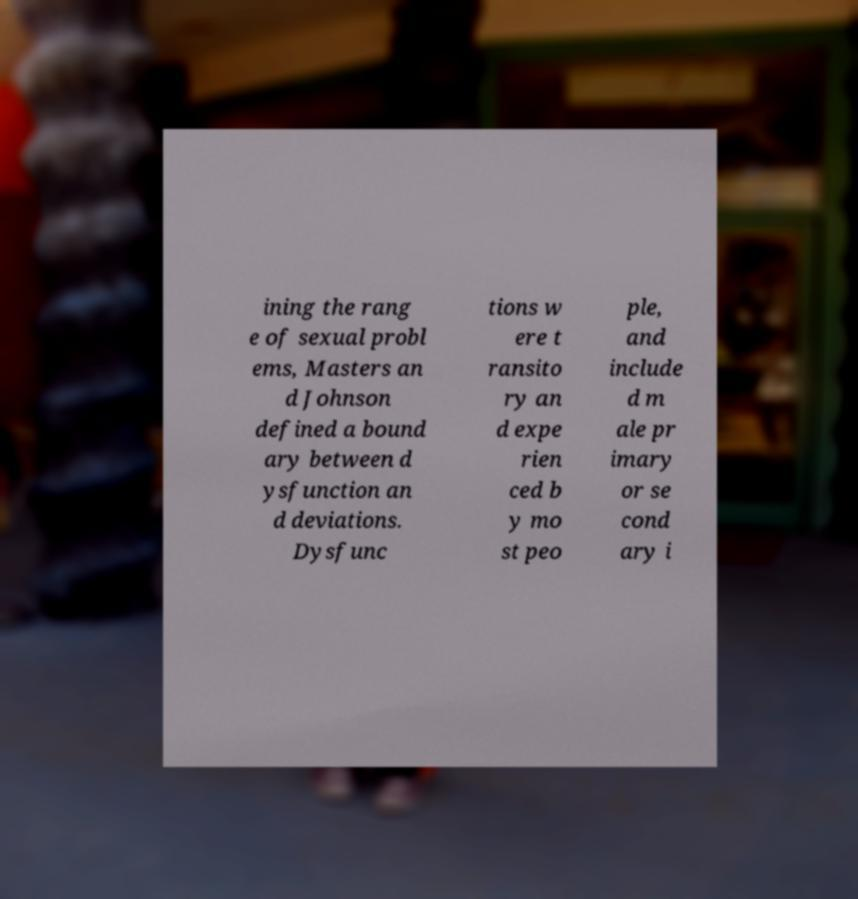Can you read and provide the text displayed in the image?This photo seems to have some interesting text. Can you extract and type it out for me? ining the rang e of sexual probl ems, Masters an d Johnson defined a bound ary between d ysfunction an d deviations. Dysfunc tions w ere t ransito ry an d expe rien ced b y mo st peo ple, and include d m ale pr imary or se cond ary i 